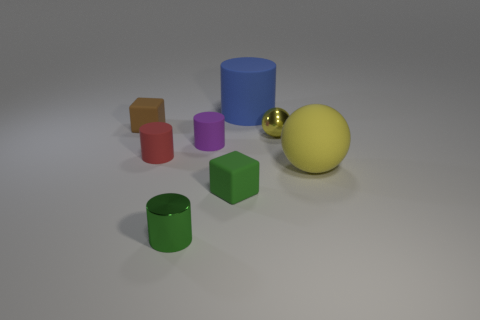What number of large balls are the same color as the small ball?
Provide a short and direct response. 1. Is the shape of the tiny red rubber thing the same as the large yellow object?
Offer a terse response. No. There is a yellow sphere to the left of the big matte object that is in front of the tiny yellow object; how big is it?
Keep it short and to the point. Small. Are there any blocks that have the same size as the metal cylinder?
Offer a very short reply. Yes. Is the size of the matte thing right of the small yellow thing the same as the blue thing right of the red thing?
Your response must be concise. Yes. There is a large thing that is in front of the rubber cube behind the tiny purple cylinder; what shape is it?
Provide a short and direct response. Sphere. What number of brown things are in front of the small green metal object?
Offer a very short reply. 0. There is another small cylinder that is the same material as the tiny red cylinder; what color is it?
Offer a terse response. Purple. There is a yellow metallic object; does it have the same size as the rubber thing that is right of the big blue cylinder?
Your answer should be very brief. No. How big is the cube that is to the right of the tiny cube to the left of the small matte cylinder that is left of the tiny green shiny cylinder?
Your response must be concise. Small. 